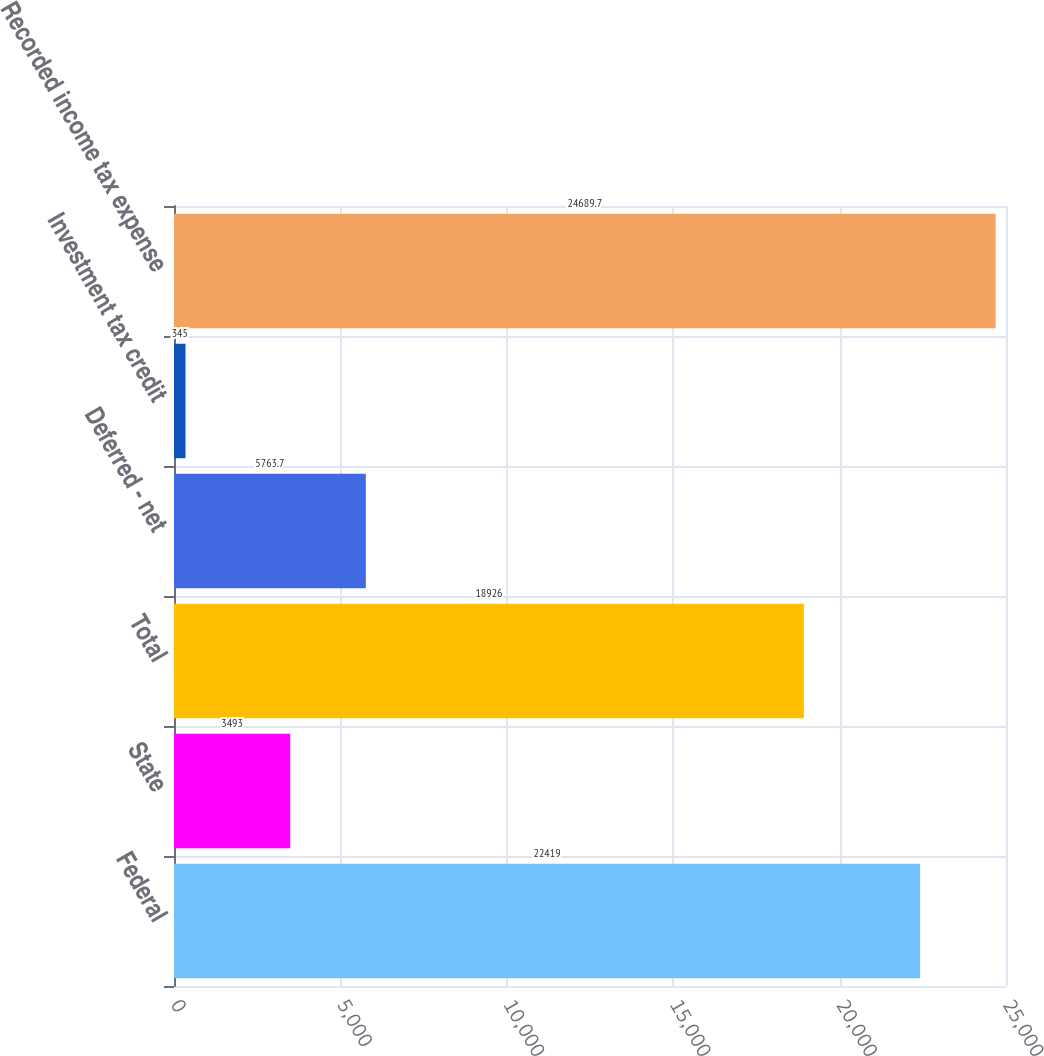Convert chart to OTSL. <chart><loc_0><loc_0><loc_500><loc_500><bar_chart><fcel>Federal<fcel>State<fcel>Total<fcel>Deferred - net<fcel>Investment tax credit<fcel>Recorded income tax expense<nl><fcel>22419<fcel>3493<fcel>18926<fcel>5763.7<fcel>345<fcel>24689.7<nl></chart> 